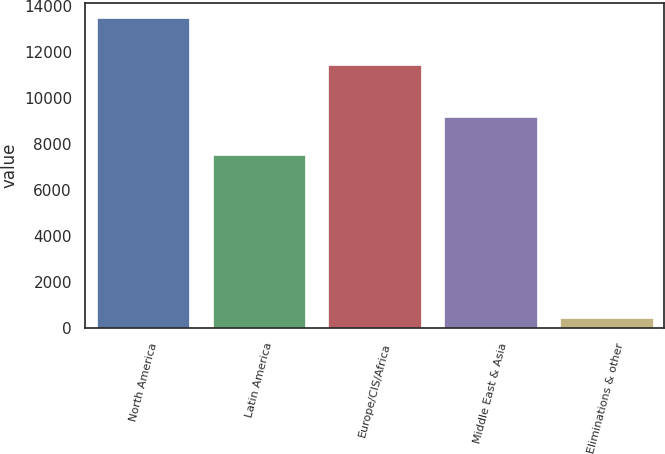Convert chart. <chart><loc_0><loc_0><loc_500><loc_500><bar_chart><fcel>North America<fcel>Latin America<fcel>Europe/CIS/Africa<fcel>Middle East & Asia<fcel>Eliminations & other<nl><fcel>13485<fcel>7554<fcel>11443<fcel>9194<fcel>473<nl></chart> 